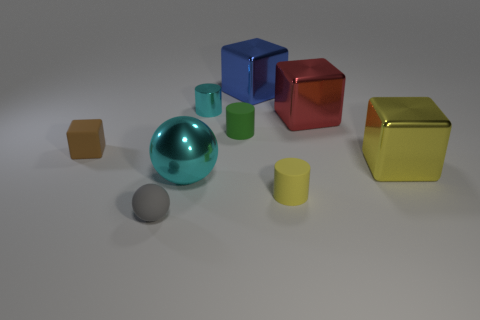Can you describe the shapes and colors of the objects in this image? Certainly! The image shows a variety of geometric shapes. There's a large cyan metallic sphere, a blue metallic cube, a red metallic cube, a green metallic cube, a yellow matte cube, two small brown matte cubes, a green matte cylinder, and a small grey matte sphere. 